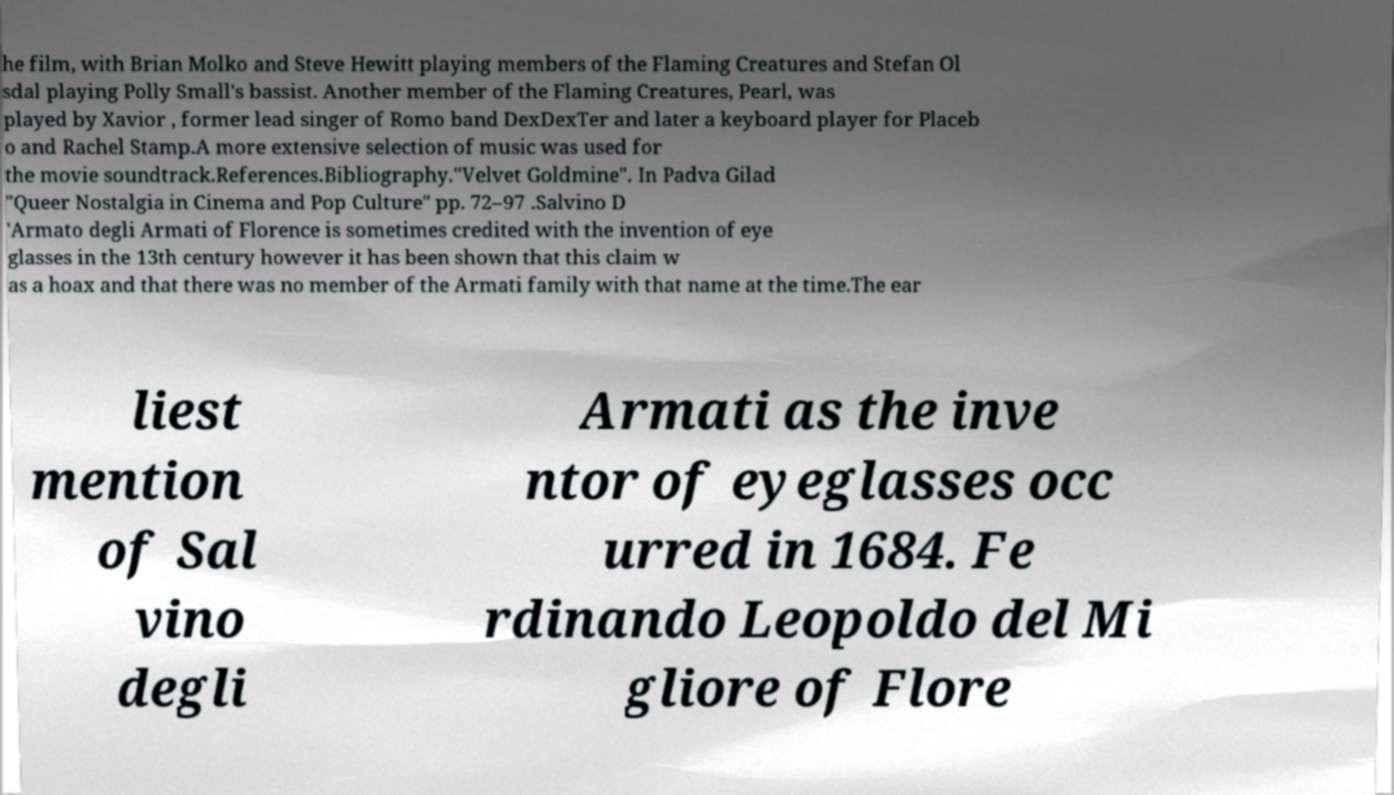Please read and relay the text visible in this image. What does it say? he film, with Brian Molko and Steve Hewitt playing members of the Flaming Creatures and Stefan Ol sdal playing Polly Small's bassist. Another member of the Flaming Creatures, Pearl, was played by Xavior , former lead singer of Romo band DexDexTer and later a keyboard player for Placeb o and Rachel Stamp.A more extensive selection of music was used for the movie soundtrack.References.Bibliography."Velvet Goldmine". In Padva Gilad "Queer Nostalgia in Cinema and Pop Culture" pp. 72–97 .Salvino D 'Armato degli Armati of Florence is sometimes credited with the invention of eye glasses in the 13th century however it has been shown that this claim w as a hoax and that there was no member of the Armati family with that name at the time.The ear liest mention of Sal vino degli Armati as the inve ntor of eyeglasses occ urred in 1684. Fe rdinando Leopoldo del Mi gliore of Flore 